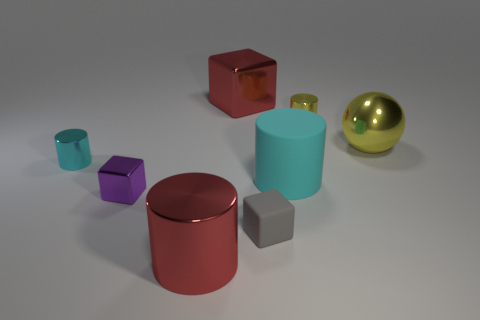Do the big cyan cylinder and the tiny gray thing have the same material?
Your answer should be very brief. Yes. What number of other things are the same shape as the tiny cyan shiny object?
Provide a succinct answer. 3. The cylinder that is behind the large ball that is behind the red shiny object that is in front of the metallic sphere is what color?
Give a very brief answer. Yellow. Is the shape of the large metallic object that is to the right of the tiny gray cube the same as  the purple thing?
Your answer should be very brief. No. What number of tiny purple shiny objects are there?
Give a very brief answer. 1. How many matte things have the same size as the red metal block?
Offer a very short reply. 1. What is the material of the big cyan thing?
Provide a short and direct response. Rubber. Is the color of the large metallic block the same as the large object in front of the small gray thing?
Make the answer very short. Yes. Is there any other thing that is the same size as the cyan metallic object?
Give a very brief answer. Yes. What size is the object that is both in front of the small cyan shiny object and behind the purple shiny block?
Make the answer very short. Large. 